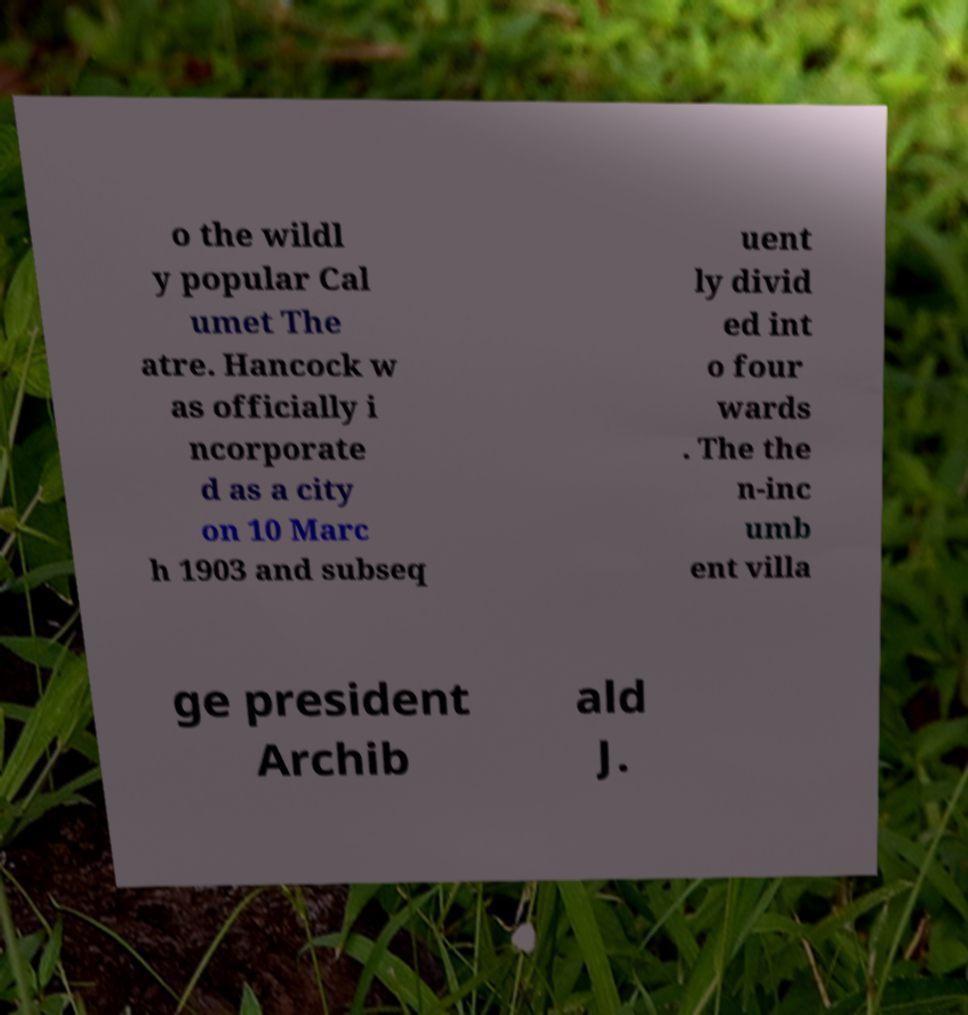Can you read and provide the text displayed in the image?This photo seems to have some interesting text. Can you extract and type it out for me? o the wildl y popular Cal umet The atre. Hancock w as officially i ncorporate d as a city on 10 Marc h 1903 and subseq uent ly divid ed int o four wards . The the n-inc umb ent villa ge president Archib ald J. 